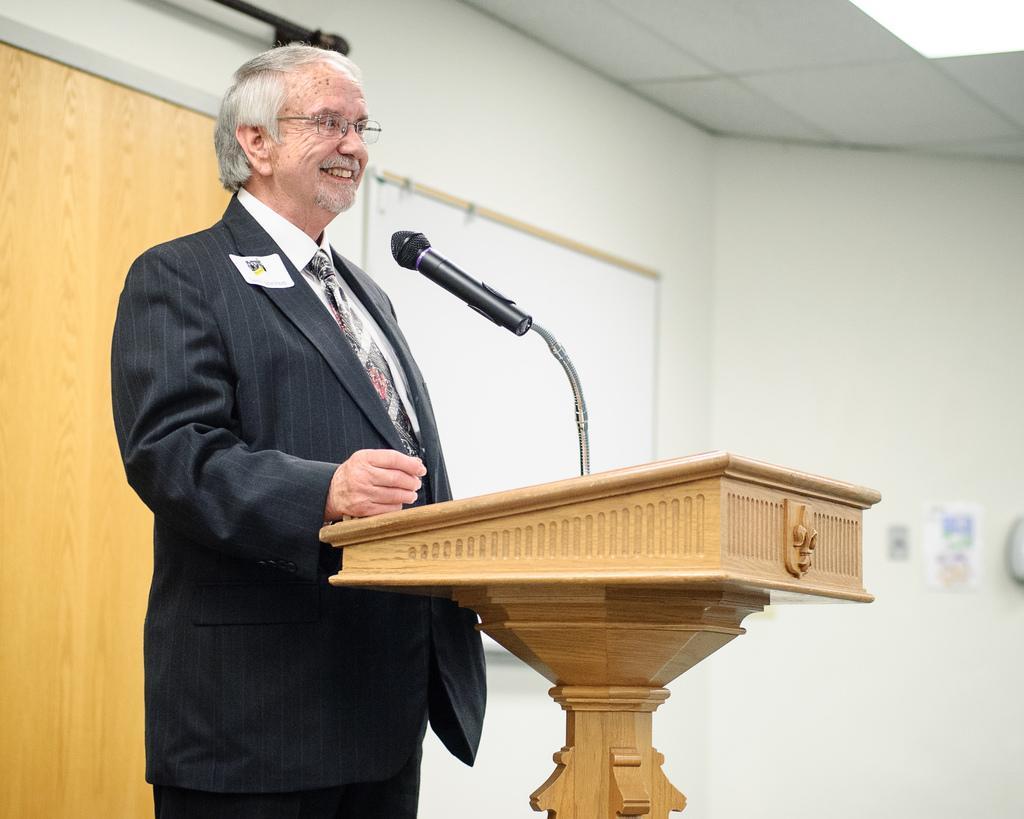In one or two sentences, can you explain what this image depicts? In this picture we can see a man is standing and smiling in front of a podium, there is a microphone on the podium, in the background we can see a wall and a board. 